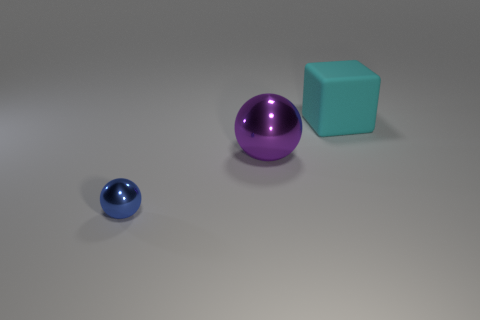Is there anything else that has the same material as the big cyan object?
Ensure brevity in your answer.  No. What is the material of the sphere that is the same size as the cyan matte thing?
Provide a short and direct response. Metal. What is the shape of the thing that is both in front of the cyan matte object and behind the blue metallic thing?
Keep it short and to the point. Sphere. What number of objects are metallic things that are left of the purple ball or big balls?
Provide a short and direct response. 2. There is a small shiny thing; is its color the same as the ball right of the tiny thing?
Your response must be concise. No. Is there anything else that has the same size as the blue object?
Make the answer very short. No. What is the size of the thing behind the large thing that is on the left side of the large cyan matte block?
Provide a short and direct response. Large. What number of objects are either red metal objects or things that are to the left of the big cyan matte block?
Offer a very short reply. 2. There is a shiny thing to the right of the small blue shiny ball; is it the same shape as the big cyan object?
Provide a short and direct response. No. There is a object left of the large object that is in front of the big cube; what number of blue things are behind it?
Provide a short and direct response. 0. 